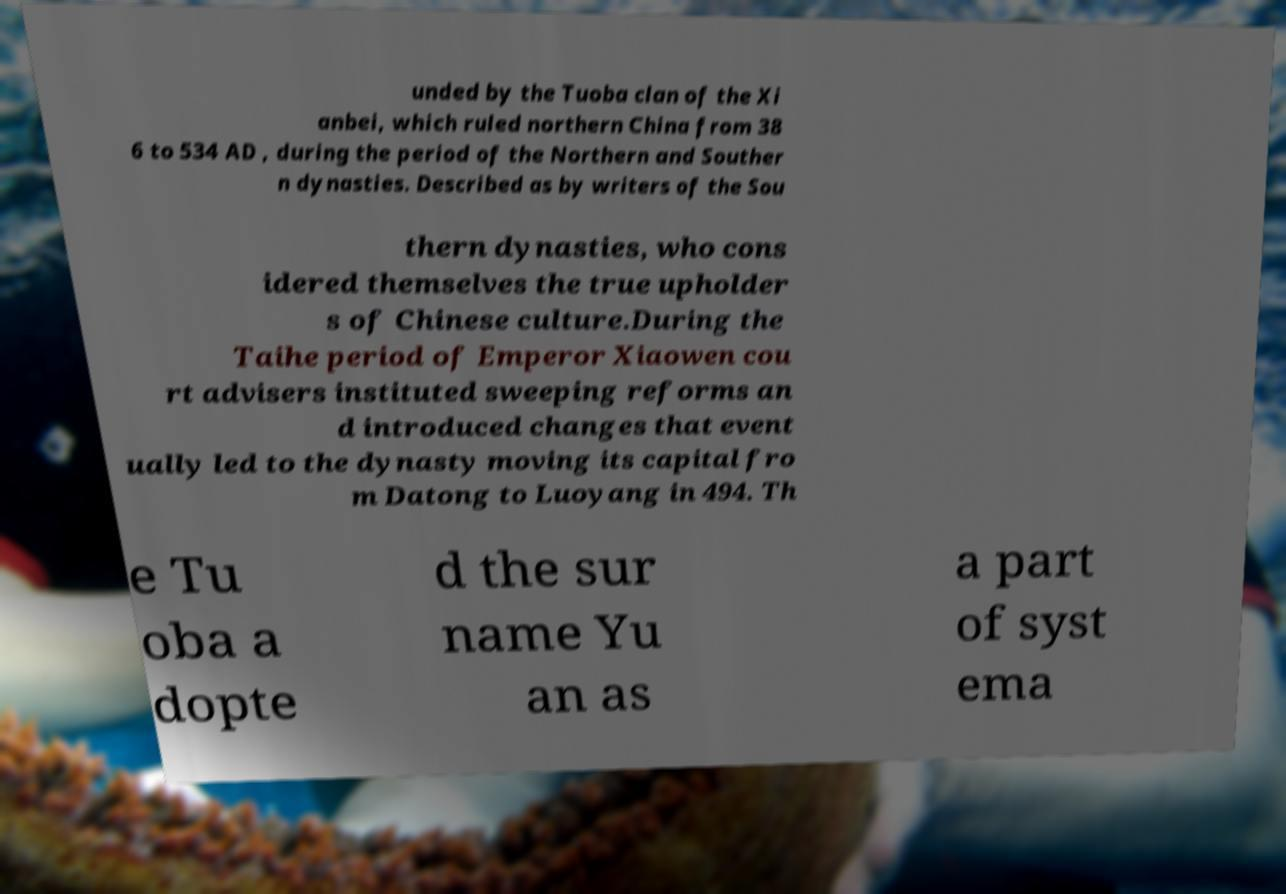For documentation purposes, I need the text within this image transcribed. Could you provide that? unded by the Tuoba clan of the Xi anbei, which ruled northern China from 38 6 to 534 AD , during the period of the Northern and Souther n dynasties. Described as by writers of the Sou thern dynasties, who cons idered themselves the true upholder s of Chinese culture.During the Taihe period of Emperor Xiaowen cou rt advisers instituted sweeping reforms an d introduced changes that event ually led to the dynasty moving its capital fro m Datong to Luoyang in 494. Th e Tu oba a dopte d the sur name Yu an as a part of syst ema 